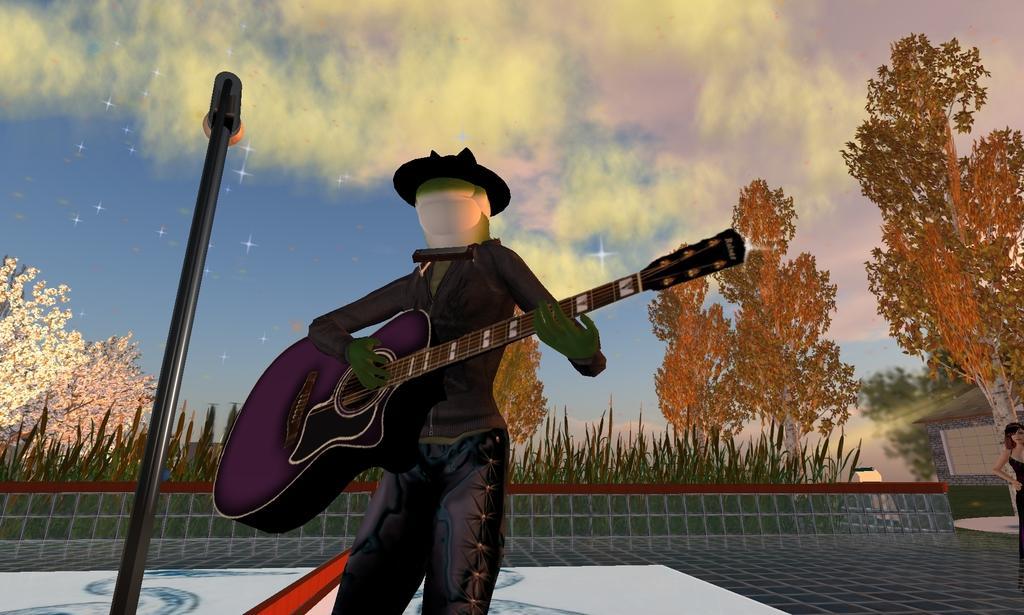How would you summarize this image in a sentence or two? In this image I can see the digital art of a person standing and holding a guitar and in the background I can see a woman standing, few plants, few trees which are white, orange and green in color and the sky. I can see the black colored metal rod and a microphone. 